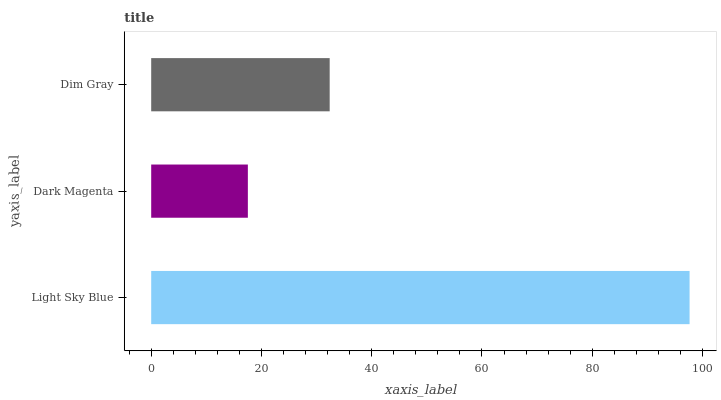Is Dark Magenta the minimum?
Answer yes or no. Yes. Is Light Sky Blue the maximum?
Answer yes or no. Yes. Is Dim Gray the minimum?
Answer yes or no. No. Is Dim Gray the maximum?
Answer yes or no. No. Is Dim Gray greater than Dark Magenta?
Answer yes or no. Yes. Is Dark Magenta less than Dim Gray?
Answer yes or no. Yes. Is Dark Magenta greater than Dim Gray?
Answer yes or no. No. Is Dim Gray less than Dark Magenta?
Answer yes or no. No. Is Dim Gray the high median?
Answer yes or no. Yes. Is Dim Gray the low median?
Answer yes or no. Yes. Is Dark Magenta the high median?
Answer yes or no. No. Is Light Sky Blue the low median?
Answer yes or no. No. 